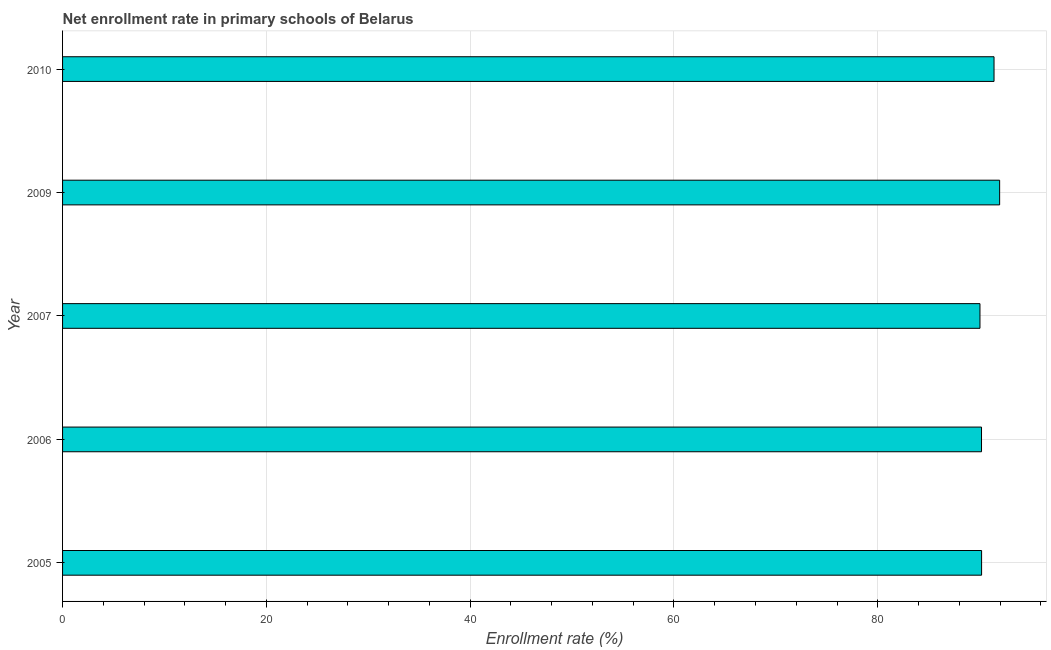Does the graph contain any zero values?
Ensure brevity in your answer.  No. Does the graph contain grids?
Your response must be concise. Yes. What is the title of the graph?
Provide a succinct answer. Net enrollment rate in primary schools of Belarus. What is the label or title of the X-axis?
Provide a short and direct response. Enrollment rate (%). What is the label or title of the Y-axis?
Offer a terse response. Year. What is the net enrollment rate in primary schools in 2010?
Keep it short and to the point. 91.41. Across all years, what is the maximum net enrollment rate in primary schools?
Give a very brief answer. 91.96. Across all years, what is the minimum net enrollment rate in primary schools?
Your answer should be very brief. 90.03. What is the sum of the net enrollment rate in primary schools?
Your response must be concise. 453.77. What is the difference between the net enrollment rate in primary schools in 2007 and 2009?
Your response must be concise. -1.93. What is the average net enrollment rate in primary schools per year?
Provide a short and direct response. 90.75. What is the median net enrollment rate in primary schools?
Your answer should be compact. 90.19. Is the net enrollment rate in primary schools in 2009 less than that in 2010?
Offer a terse response. No. Is the difference between the net enrollment rate in primary schools in 2005 and 2010 greater than the difference between any two years?
Your answer should be compact. No. What is the difference between the highest and the second highest net enrollment rate in primary schools?
Your answer should be compact. 0.55. Is the sum of the net enrollment rate in primary schools in 2006 and 2010 greater than the maximum net enrollment rate in primary schools across all years?
Provide a short and direct response. Yes. What is the difference between the highest and the lowest net enrollment rate in primary schools?
Your answer should be very brief. 1.93. In how many years, is the net enrollment rate in primary schools greater than the average net enrollment rate in primary schools taken over all years?
Make the answer very short. 2. How many years are there in the graph?
Make the answer very short. 5. What is the difference between two consecutive major ticks on the X-axis?
Make the answer very short. 20. What is the Enrollment rate (%) of 2005?
Your answer should be compact. 90.19. What is the Enrollment rate (%) of 2006?
Keep it short and to the point. 90.18. What is the Enrollment rate (%) of 2007?
Your answer should be compact. 90.03. What is the Enrollment rate (%) of 2009?
Provide a succinct answer. 91.96. What is the Enrollment rate (%) of 2010?
Make the answer very short. 91.41. What is the difference between the Enrollment rate (%) in 2005 and 2006?
Make the answer very short. 0.01. What is the difference between the Enrollment rate (%) in 2005 and 2007?
Keep it short and to the point. 0.16. What is the difference between the Enrollment rate (%) in 2005 and 2009?
Your answer should be compact. -1.77. What is the difference between the Enrollment rate (%) in 2005 and 2010?
Your response must be concise. -1.22. What is the difference between the Enrollment rate (%) in 2006 and 2007?
Your response must be concise. 0.15. What is the difference between the Enrollment rate (%) in 2006 and 2009?
Keep it short and to the point. -1.78. What is the difference between the Enrollment rate (%) in 2006 and 2010?
Provide a succinct answer. -1.23. What is the difference between the Enrollment rate (%) in 2007 and 2009?
Provide a short and direct response. -1.93. What is the difference between the Enrollment rate (%) in 2007 and 2010?
Make the answer very short. -1.38. What is the difference between the Enrollment rate (%) in 2009 and 2010?
Your answer should be very brief. 0.55. What is the ratio of the Enrollment rate (%) in 2005 to that in 2009?
Give a very brief answer. 0.98. What is the ratio of the Enrollment rate (%) in 2006 to that in 2010?
Your answer should be very brief. 0.99. What is the ratio of the Enrollment rate (%) in 2009 to that in 2010?
Your answer should be compact. 1.01. 